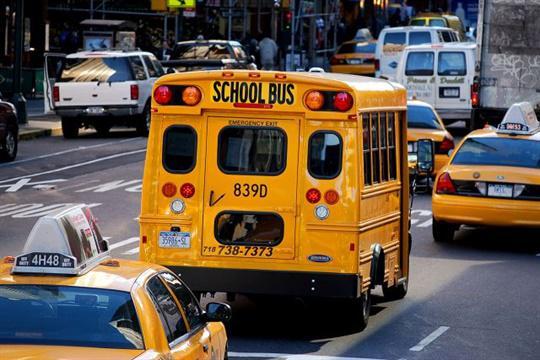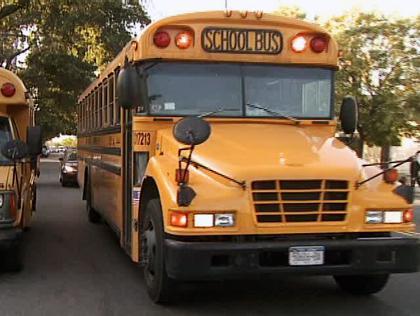The first image is the image on the left, the second image is the image on the right. Analyze the images presented: Is the assertion "In one of the images you can see the tail lights of a school bus." valid? Answer yes or no. Yes. The first image is the image on the left, the second image is the image on the right. For the images shown, is this caption "The left image shows at least one bus heading away from the camera, and the right image shows at least one forward-angled bus." true? Answer yes or no. Yes. 